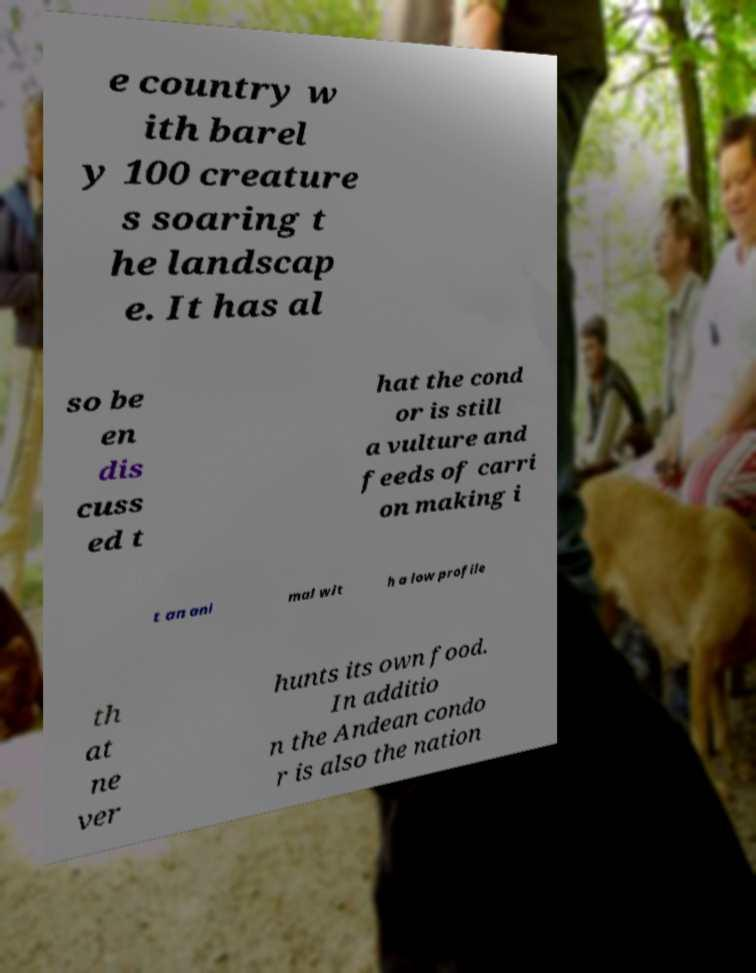Could you assist in decoding the text presented in this image and type it out clearly? e country w ith barel y 100 creature s soaring t he landscap e. It has al so be en dis cuss ed t hat the cond or is still a vulture and feeds of carri on making i t an ani mal wit h a low profile th at ne ver hunts its own food. In additio n the Andean condo r is also the nation 